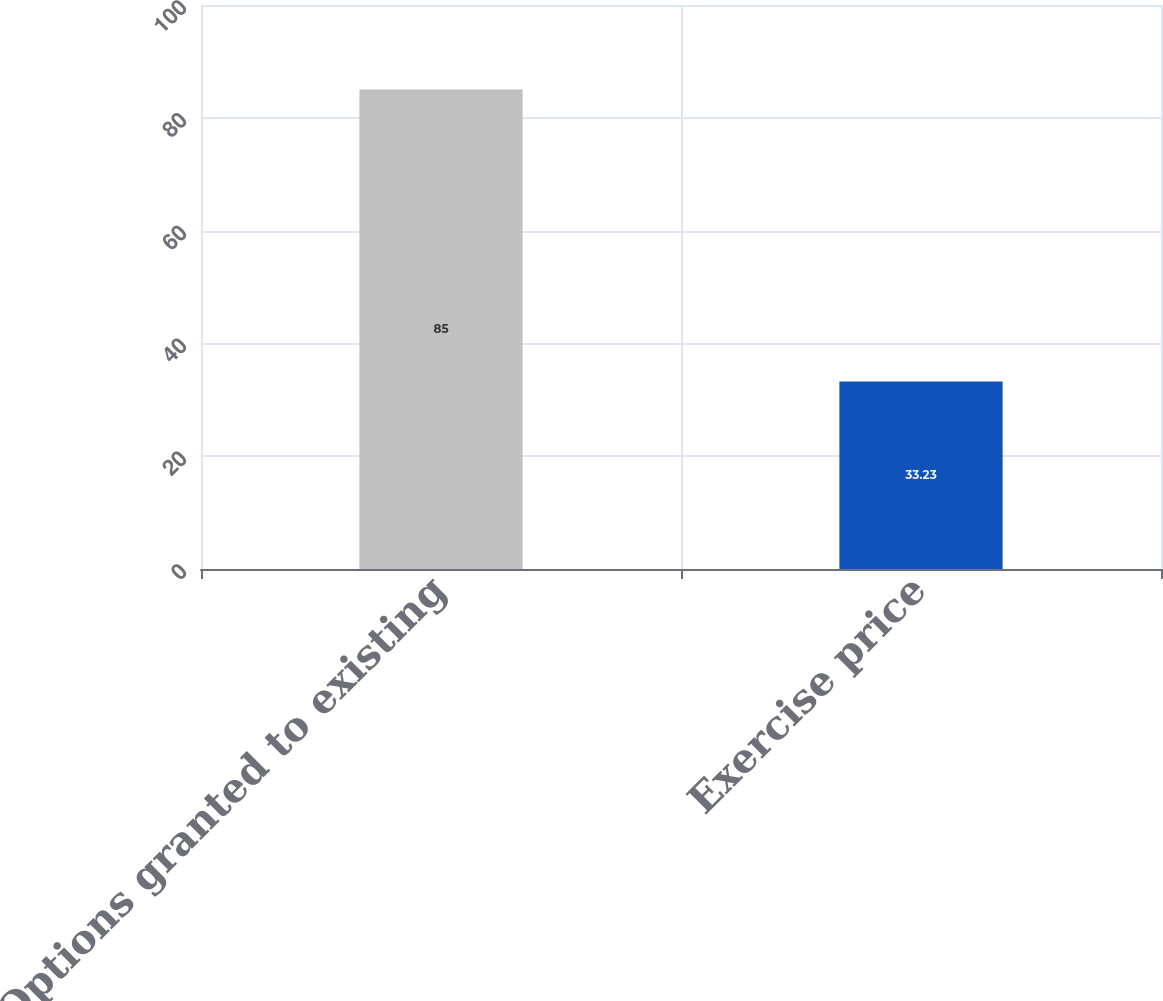<chart> <loc_0><loc_0><loc_500><loc_500><bar_chart><fcel>Options granted to existing<fcel>Exercise price<nl><fcel>85<fcel>33.23<nl></chart> 